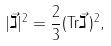<formula> <loc_0><loc_0><loc_500><loc_500>| \vec { \gimel } | ^ { 2 } = \frac { 2 } { 3 } ( { \tt T r } \vec { \gimel } \, ) ^ { 2 } ,</formula> 